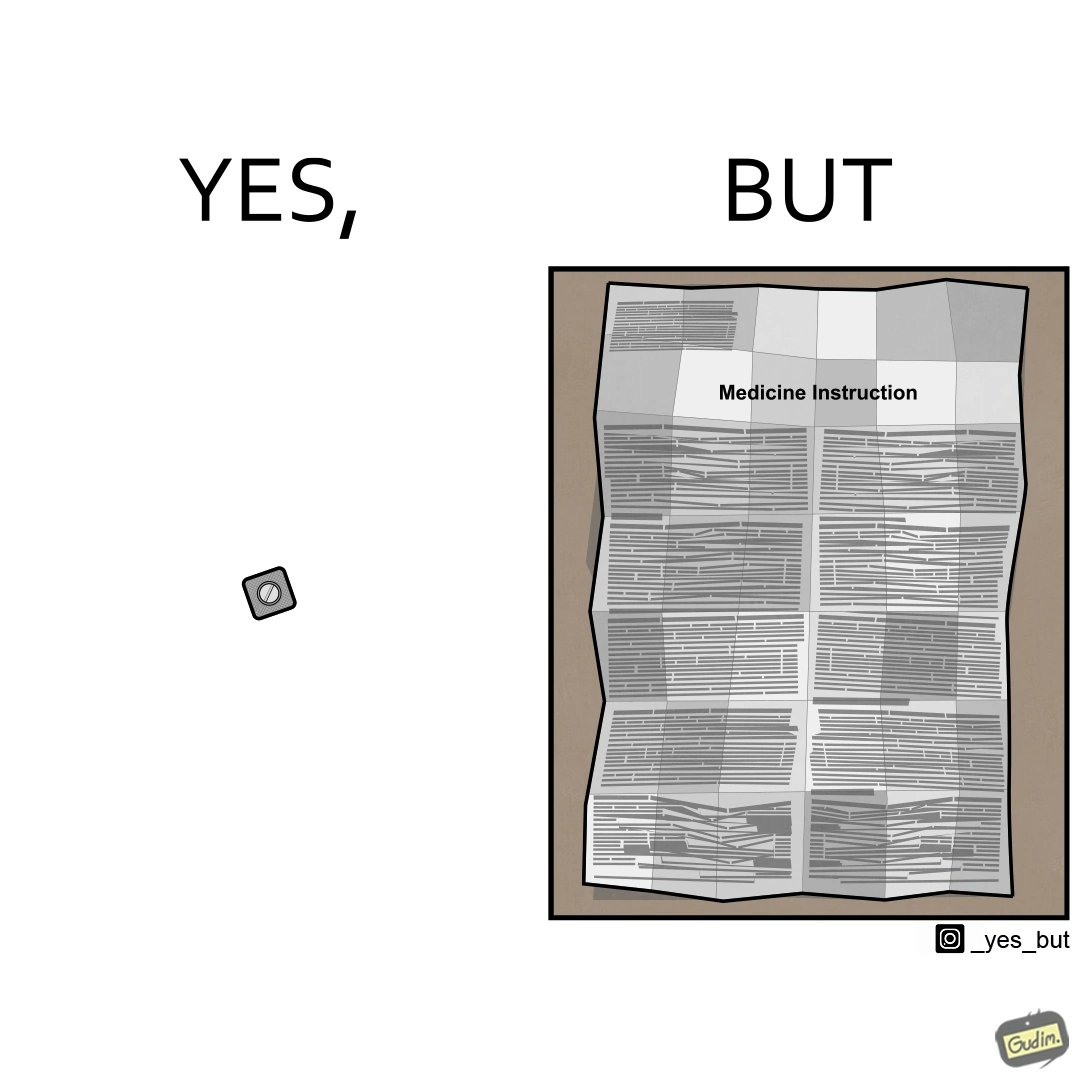Is this image satirical or non-satirical? Yes, this image is satirical. 